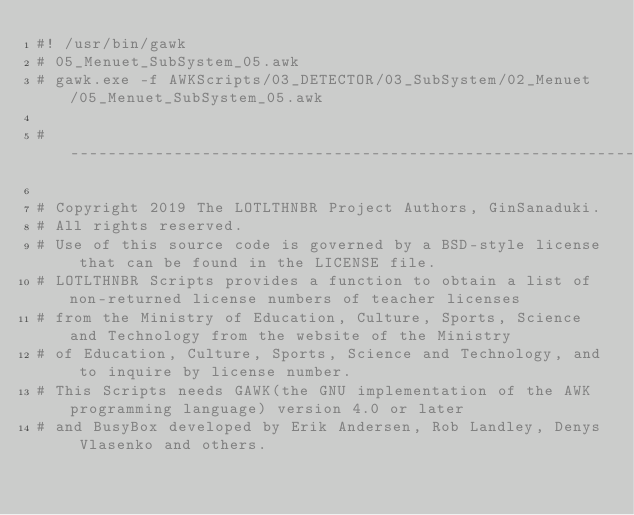Convert code to text. <code><loc_0><loc_0><loc_500><loc_500><_Awk_>#! /usr/bin/gawk
# 05_Menuet_SubSystem_05.awk
# gawk.exe -f AWKScripts/03_DETECTOR/03_SubSystem/02_Menuet/05_Menuet_SubSystem_05.awk

# ------------------------------------------------------------------------------------------------------------------------

# Copyright 2019 The LOTLTHNBR Project Authors, GinSanaduki.
# All rights reserved.
# Use of this source code is governed by a BSD-style license that can be found in the LICENSE file.
# LOTLTHNBR Scripts provides a function to obtain a list of non-returned license numbers of teacher licenses 
# from the Ministry of Education, Culture, Sports, Science and Technology from the website of the Ministry 
# of Education, Culture, Sports, Science and Technology, and to inquire by license number.
# This Scripts needs GAWK(the GNU implementation of the AWK programming language) version 4.0 or later 
# and BusyBox developed by Erik Andersen, Rob Landley, Denys Vlasenko and others.</code> 